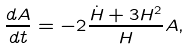Convert formula to latex. <formula><loc_0><loc_0><loc_500><loc_500>\frac { d A } { d t } = - 2 \frac { \dot { H } + 3 H ^ { 2 } } { H } A ,</formula> 